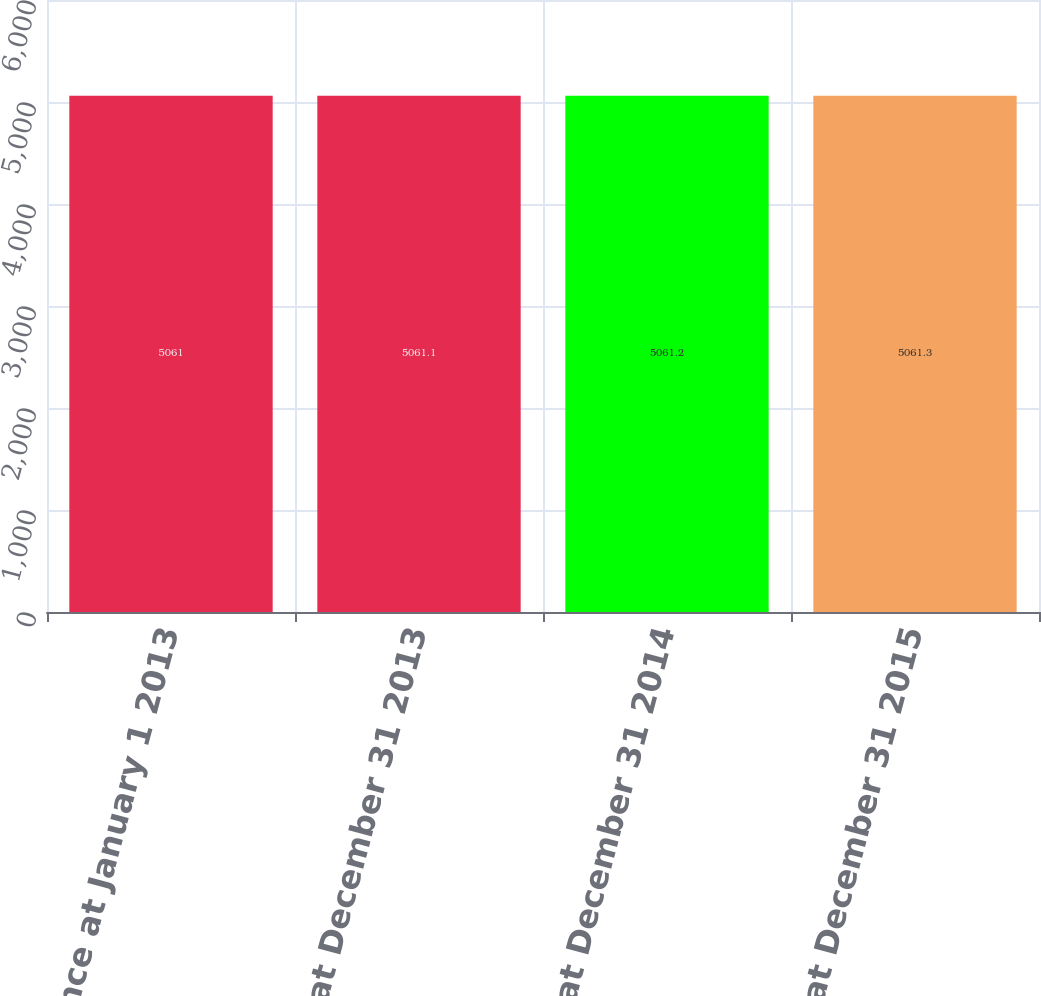Convert chart to OTSL. <chart><loc_0><loc_0><loc_500><loc_500><bar_chart><fcel>Balance at January 1 2013<fcel>Balance at December 31 2013<fcel>Balance at December 31 2014<fcel>Balance at December 31 2015<nl><fcel>5061<fcel>5061.1<fcel>5061.2<fcel>5061.3<nl></chart> 